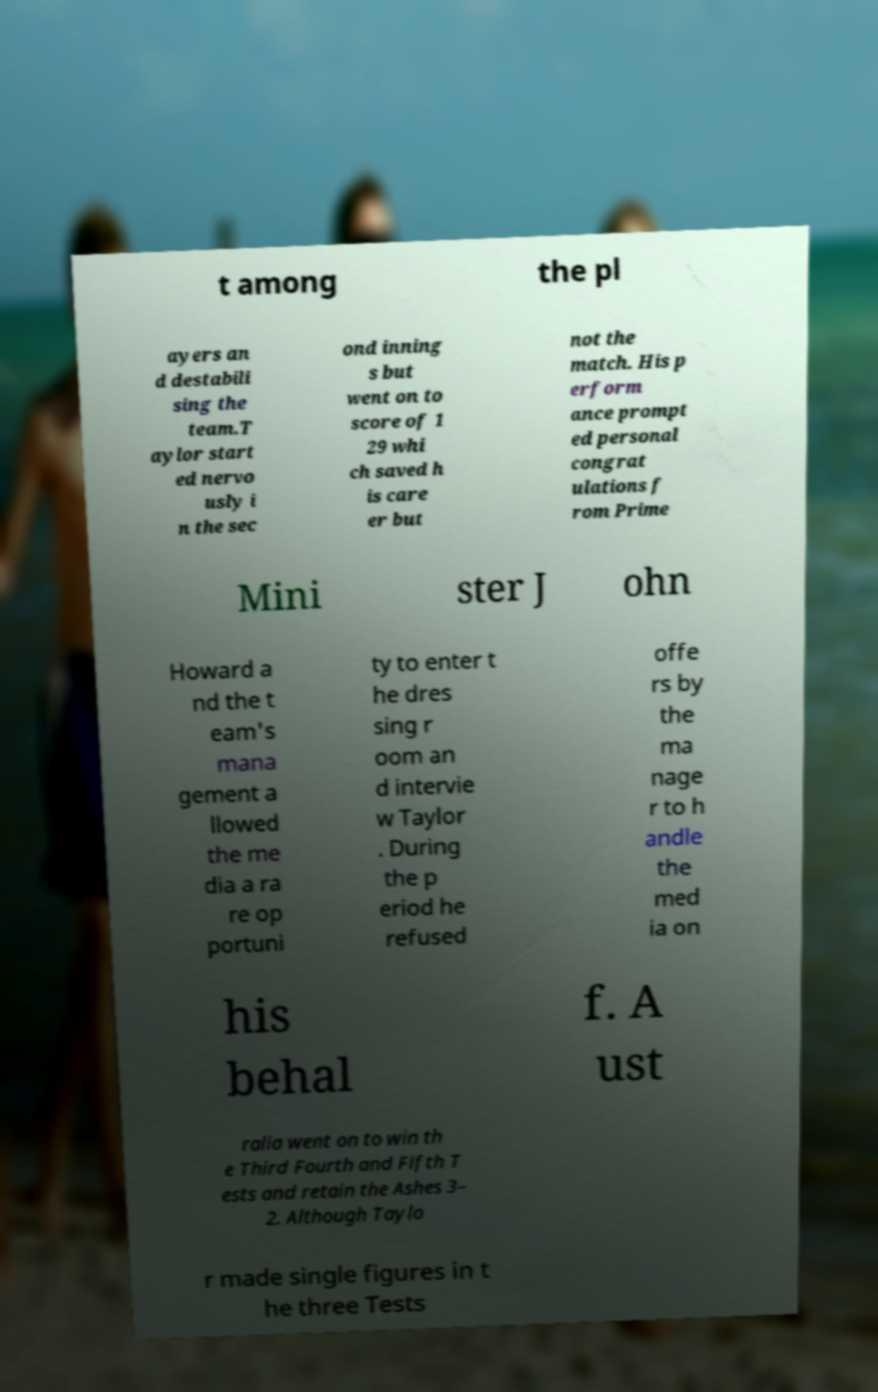Can you accurately transcribe the text from the provided image for me? t among the pl ayers an d destabili sing the team.T aylor start ed nervo usly i n the sec ond inning s but went on to score of 1 29 whi ch saved h is care er but not the match. His p erform ance prompt ed personal congrat ulations f rom Prime Mini ster J ohn Howard a nd the t eam's mana gement a llowed the me dia a ra re op portuni ty to enter t he dres sing r oom an d intervie w Taylor . During the p eriod he refused offe rs by the ma nage r to h andle the med ia on his behal f. A ust ralia went on to win th e Third Fourth and Fifth T ests and retain the Ashes 3– 2. Although Taylo r made single figures in t he three Tests 